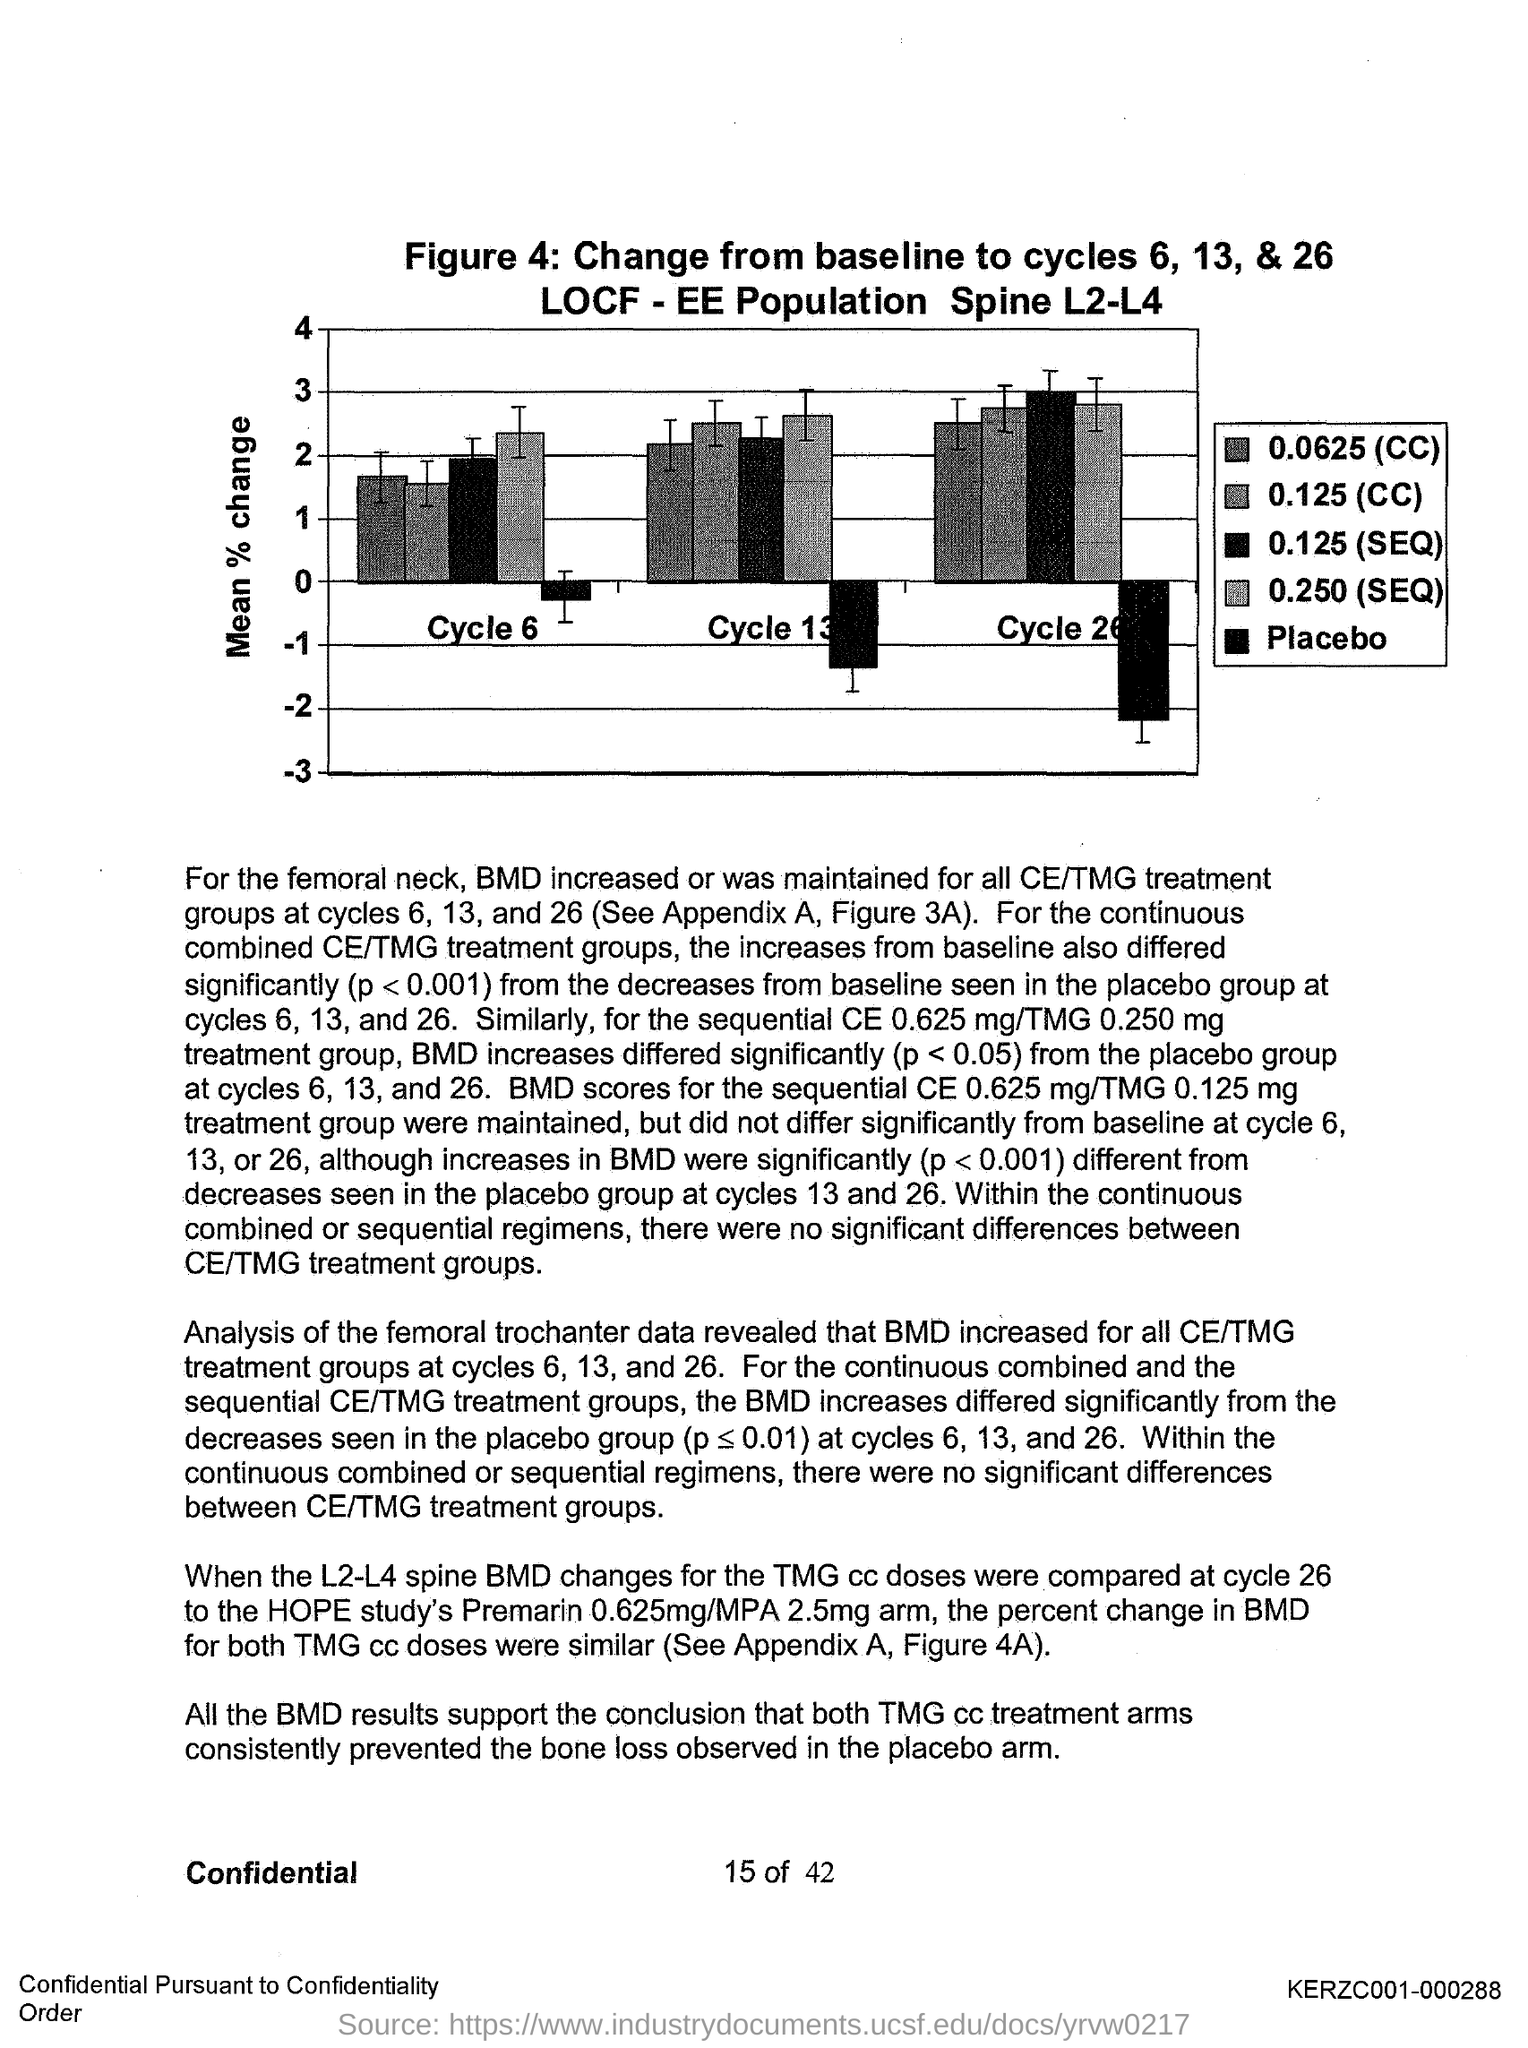What is the "Y-axis"?
Your response must be concise. MEAN % CHANGE. What is the Page Number?
Provide a succinct answer. 15. 